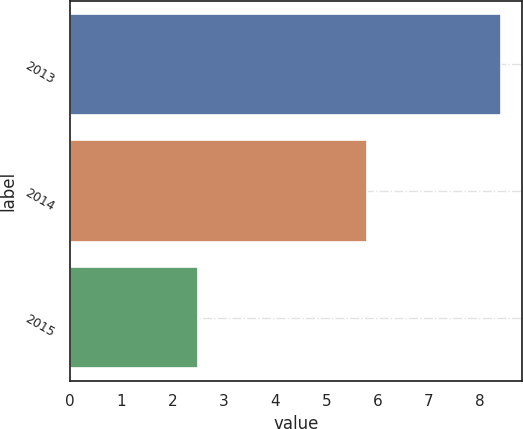Convert chart. <chart><loc_0><loc_0><loc_500><loc_500><bar_chart><fcel>2013<fcel>2014<fcel>2015<nl><fcel>8.4<fcel>5.8<fcel>2.5<nl></chart> 